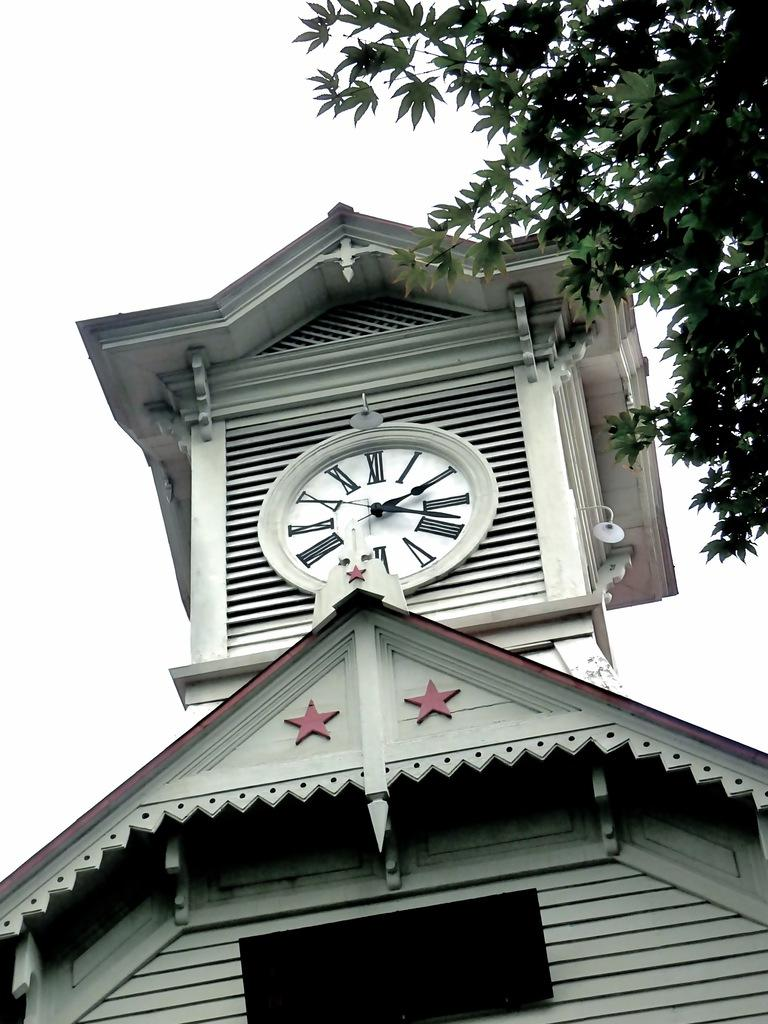<image>
Offer a succinct explanation of the picture presented. A clock on a building shows a time of almost two twenty. 